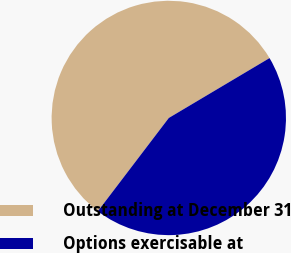<chart> <loc_0><loc_0><loc_500><loc_500><pie_chart><fcel>Outstanding at December 31<fcel>Options exercisable at<nl><fcel>56.11%<fcel>43.89%<nl></chart> 